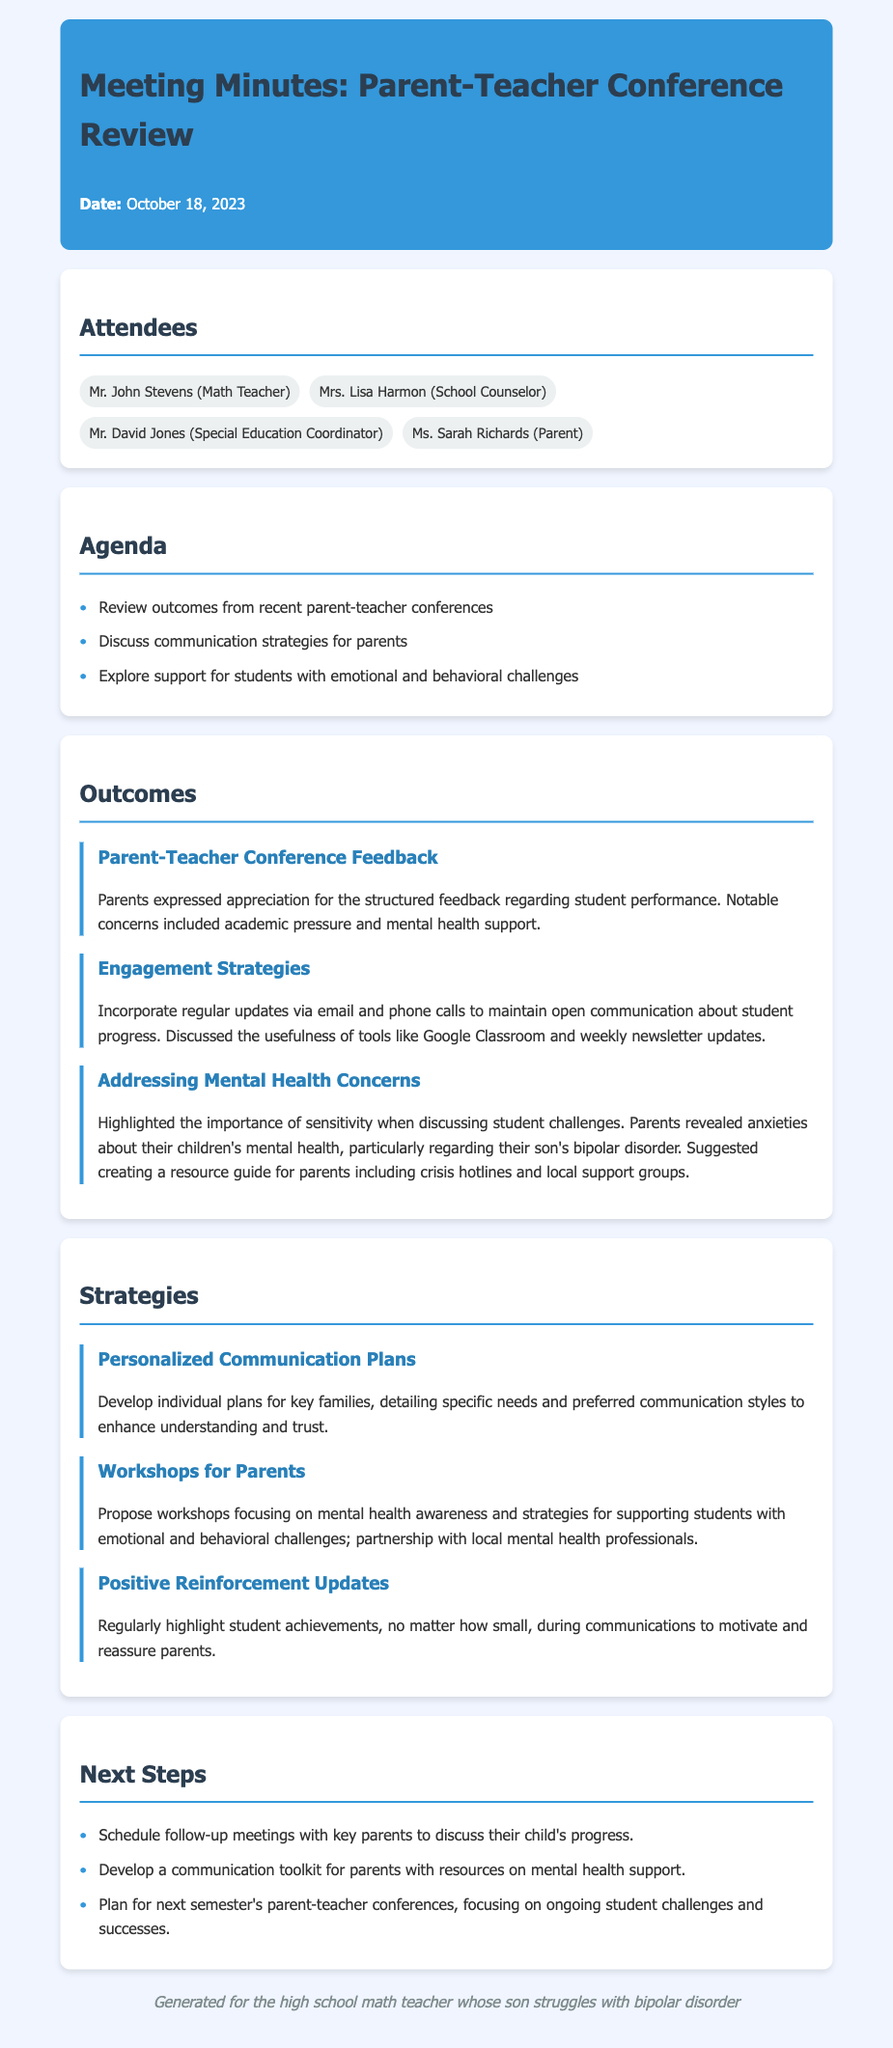What is the date of the meeting? The date of the meeting is mentioned in the header of the document.
Answer: October 18, 2023 Who is the special education coordinator present at the meeting? This information is found in the list of attendees.
Answer: Mr. David Jones What was a notable concern expressed by parents? This concern is highlighted in the outcome section.
Answer: Mental health support What is one communication strategy discussed in the meeting? The strategies for communication are outlined in the strategies section.
Answer: Personalized Communication Plans Which workshop was proposed during the meeting? The strategies section includes a proposed workshop topic.
Answer: Workshops for Parents What is one next step mentioned in the document? The next steps are listed at the end of the document.
Answer: Schedule follow-up meetings with key parents How did parents feel about the feedback on student performance? This is outlined in the outcome section regarding the parent-teacher conference feedback.
Answer: Appreciation What is suggested to create for parents to support mental health? This suggestion is made under addressing mental health concerns in the outcomes.
Answer: Resource guide 